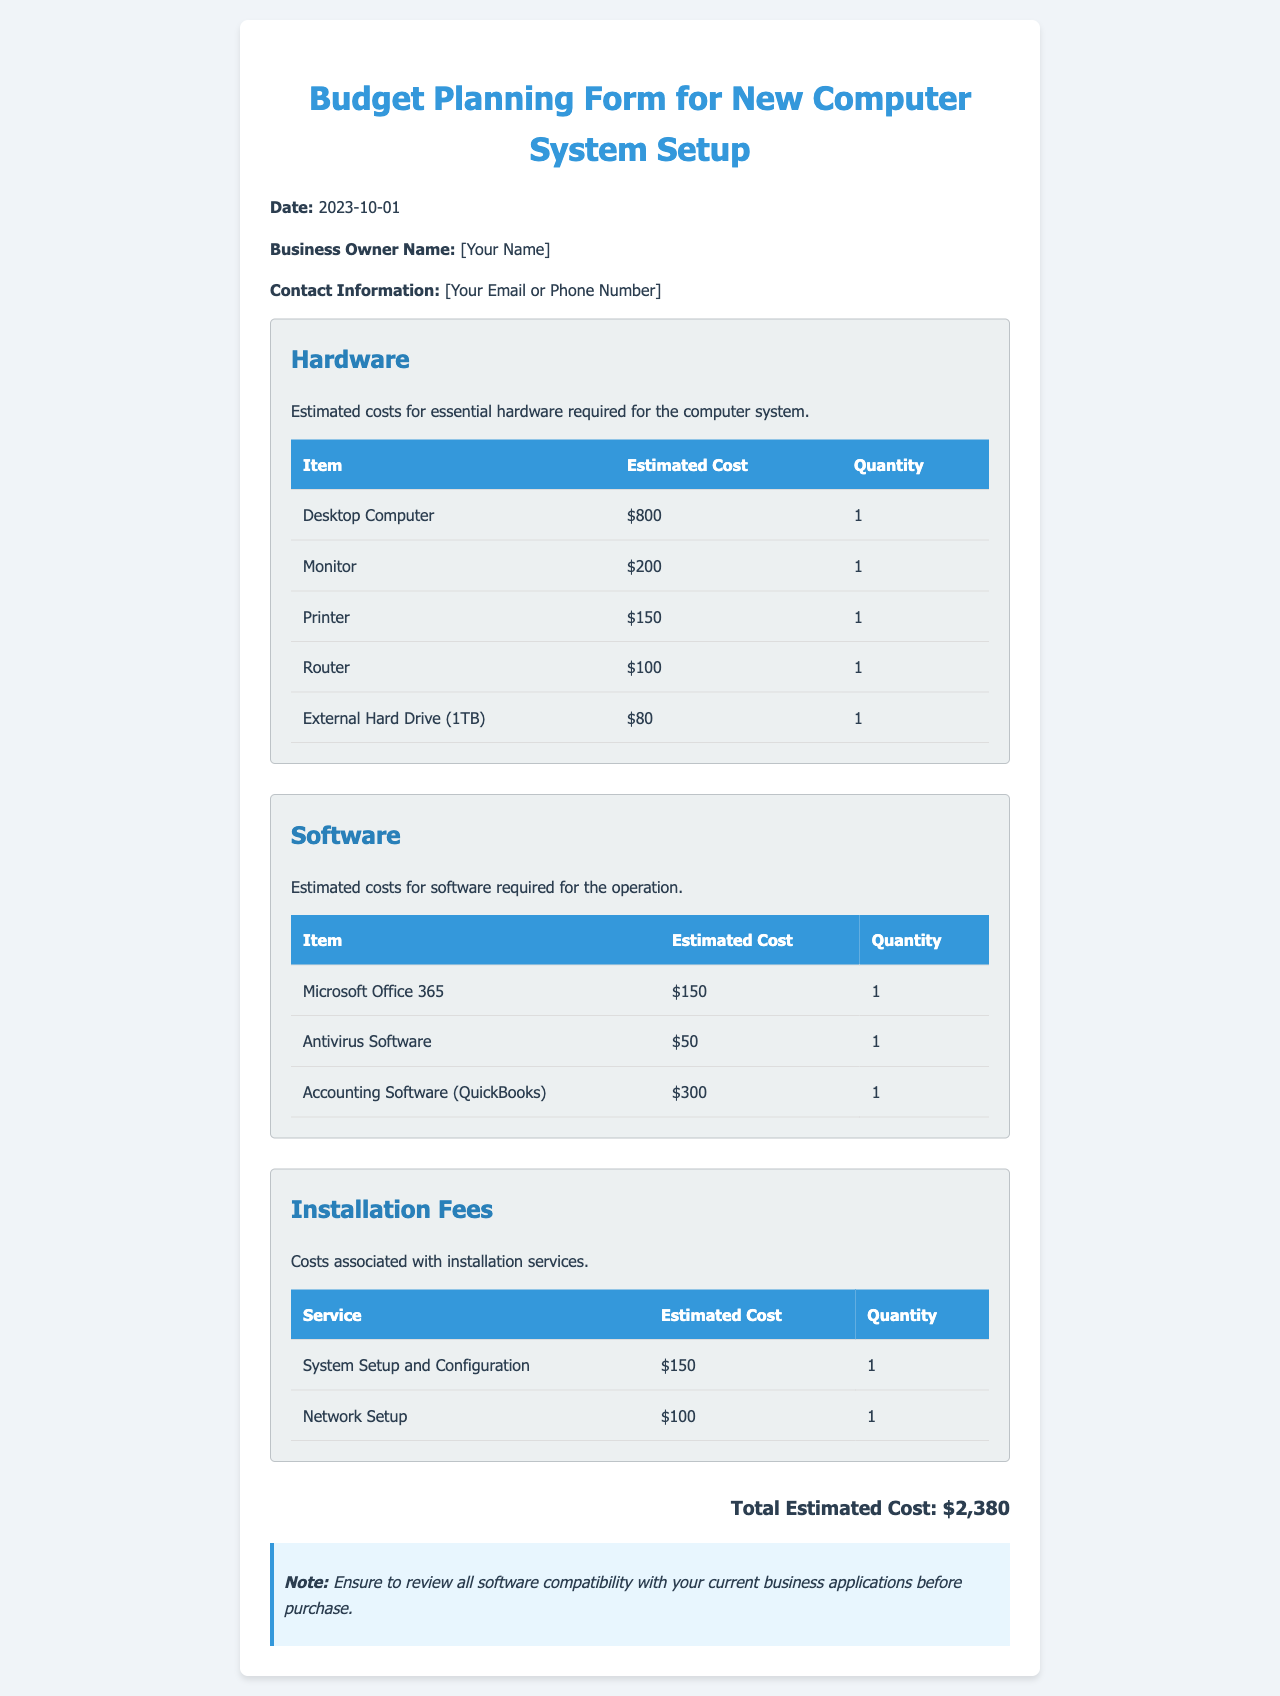what is the date of the document? The date of the document is clearly stated at the top of the form.
Answer: 2023-10-01 who is the business owner? The owner's name is indicated in the appropriate section of the form.
Answer: [Your Name] what is the estimated cost of the desktop computer? The cost for the desktop computer is listed in the hardware section of the document.
Answer: $800 how many printers are included in the budget? The quantity of printers is specified in the hardware section of the table.
Answer: 1 what is the total estimated cost for the computer system setup? The total cost is calculated by summing all expenses detailed in the document.
Answer: $2,380 what is included in the software costs? The software costs section outlines the items that need to be purchased for the system.
Answer: Microsoft Office 365, Antivirus Software, Accounting Software what service costs are associated with installation? This refers to the services mentioned in the installation fees section.
Answer: System Setup and Configuration, Network Setup how much does the antivirus software cost? The cost of antivirus software is explicitly stated in the software table.
Answer: $50 what note is provided at the end of the document? A note is added to remind the reader about software compatibility.
Answer: Ensure to review all software compatibility with your current business applications before purchase 